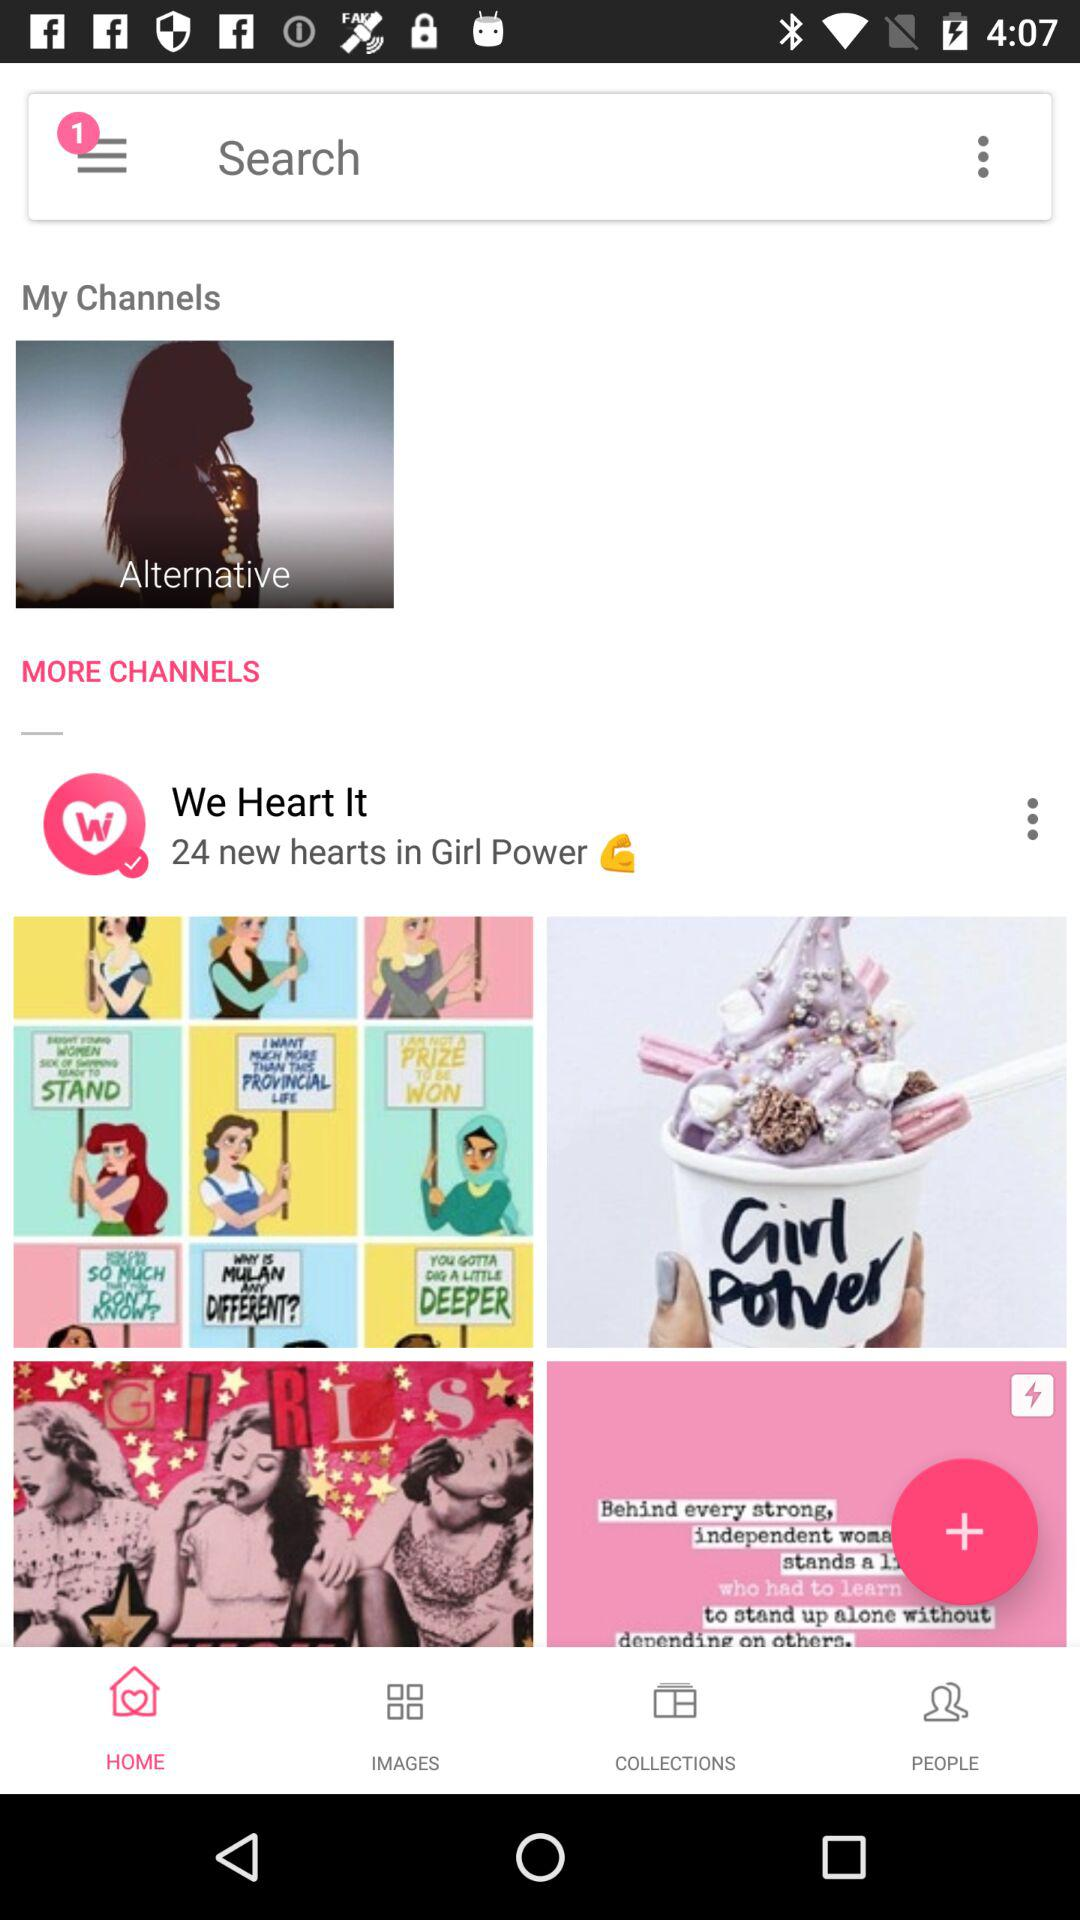What is the name of the application? The name of the application is "We Heart It". 